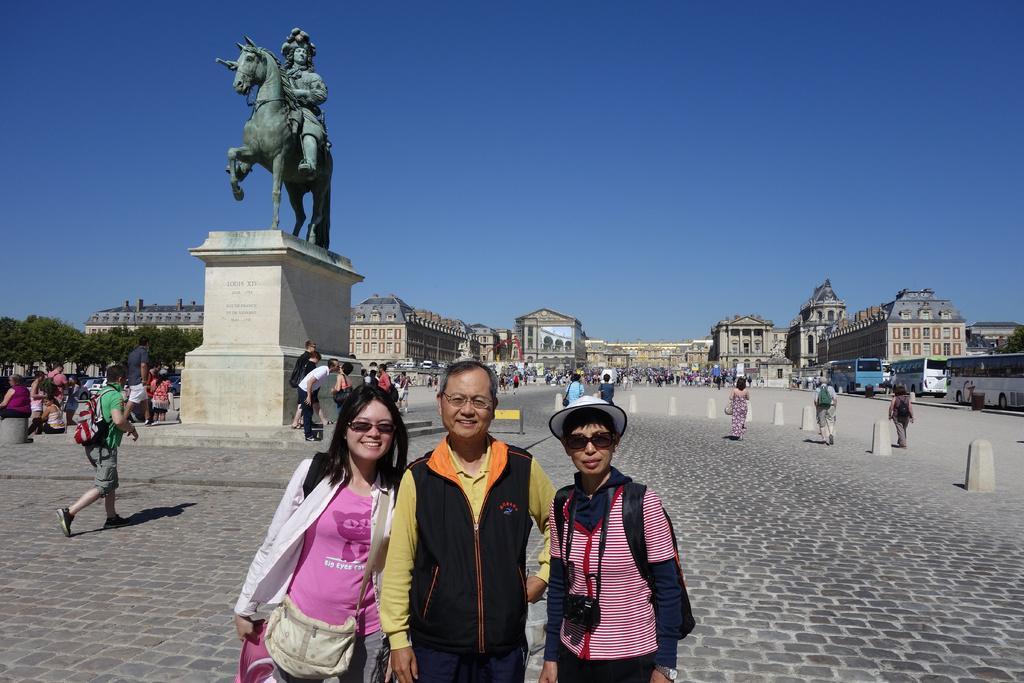How would you summarize this image in a sentence or two? In this image there are people. On the left there is a sculpture and we can see buildings. There are vehicles on the road. On the left there are trees. In the background there is sky. 